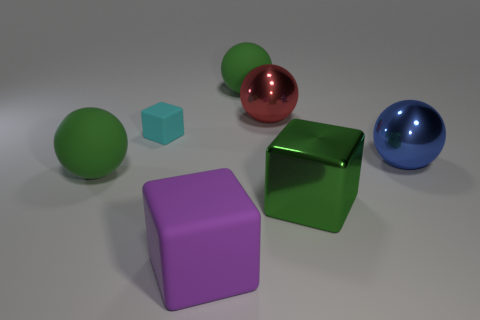Add 2 big rubber things. How many objects exist? 9 Subtract all gray balls. Subtract all purple cubes. How many balls are left? 4 Subtract all balls. How many objects are left? 3 Add 5 large green matte objects. How many large green matte objects exist? 7 Subtract 0 gray spheres. How many objects are left? 7 Subtract all large red things. Subtract all metallic things. How many objects are left? 3 Add 2 big purple matte cubes. How many big purple matte cubes are left? 3 